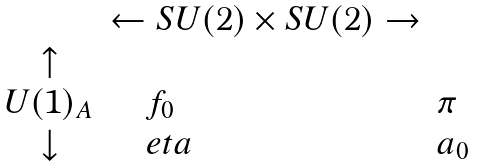<formula> <loc_0><loc_0><loc_500><loc_500>\begin{array} { c l l } & \leftarrow S U ( 2 ) \times S U ( 2 ) \rightarrow \\ \uparrow \\ U ( 1 ) _ { A } & \quad f _ { 0 } & \pi \\ \downarrow & \quad e t a & a _ { 0 } \end{array}</formula> 